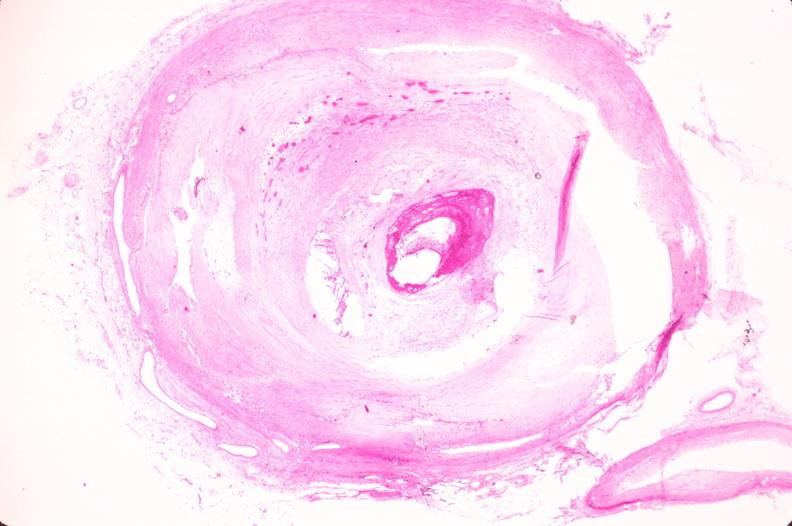where is this in?
Answer the question using a single word or phrase. In vasculature 